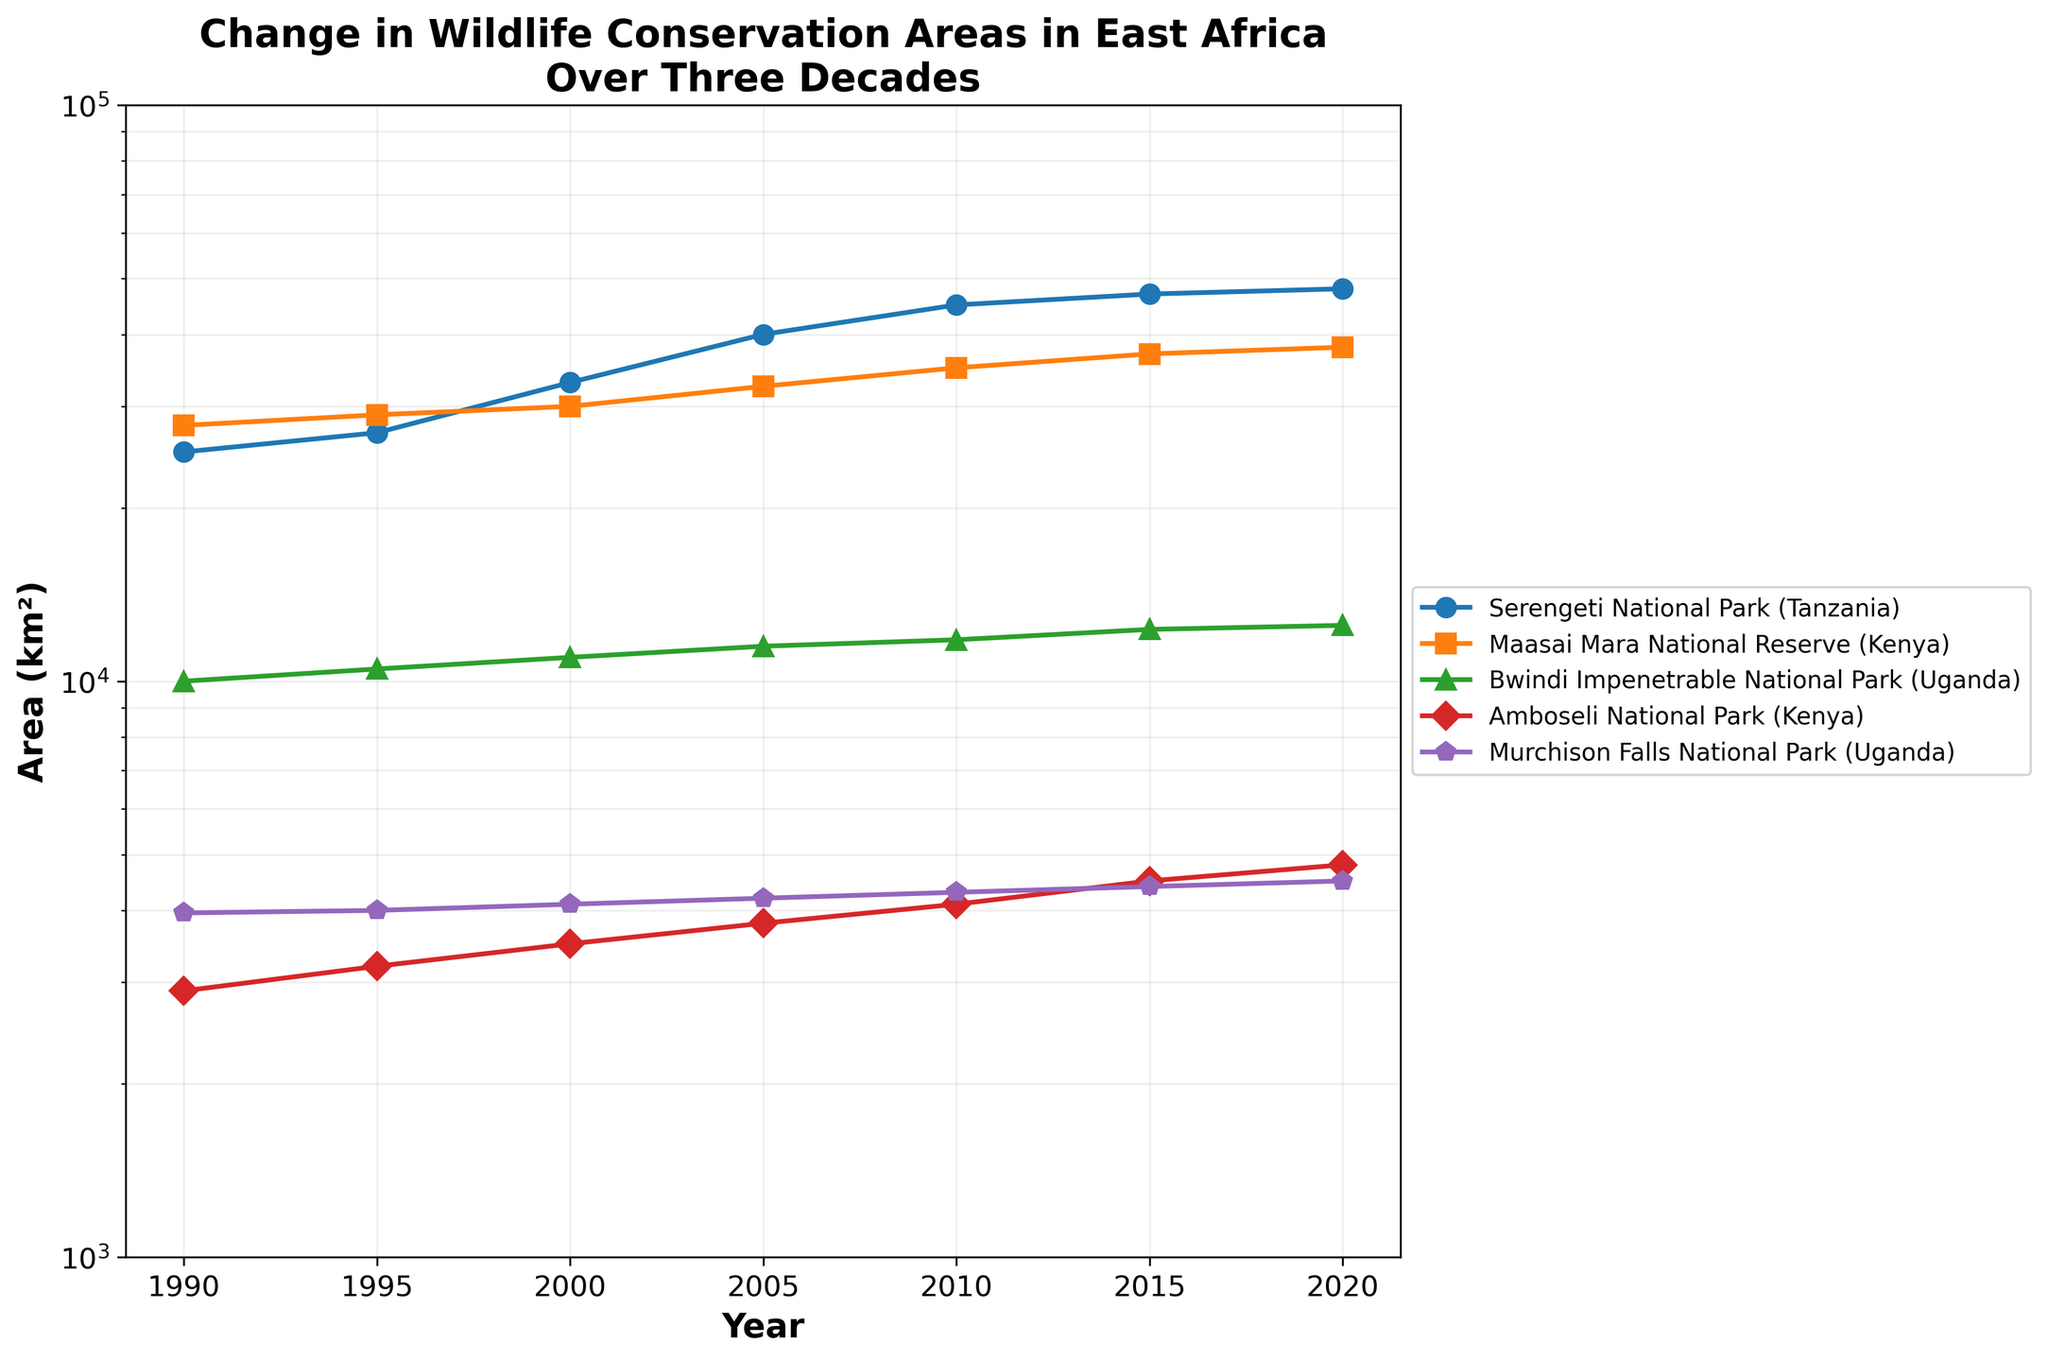What is the title of the figure? The title is prominently displayed at the top of the figure in bold font, describing the subject of the plot.
Answer: Change in Wildlife Conservation Areas in East Africa Over Three Decades Which national park had the largest conservation area in 2000? By looking at the 2000 data points on the plot for each park, we notice that Serengeti National Park has the highest value.
Answer: Serengeti National Park How many years are represented in the figure? Counting the data points on the x-axis, we see that there are seven different years represented.
Answer: 7 By how much did the area of Bwindi Impenetrable National Park increase from 1990 to 2020? The values for Bwindi Impenetrable National Park in 1990 and 2020 are 10,000 and 12,500 km² respectively. The increase is 12,500 - 10,000.
Answer: 2,500 km² Which park showed the most consistent increase over the years? By examining the slopes of the lines, Serengeti National Park displays a steady and significant increase without any decreases or plateaus.
Answer: Serengeti National Park Which conservation area had the smallest size in 1990? Looking at the data points for 1990 along the y-axis, Amboseli National Park has the smallest value.
Answer: Amboseli National Park In which year did Serengeti National Park surpass 40,000 km²? By following the Serengeti National Park line, it crosses the 40,000 km² threshold between 2000 and 2005. The closest year indicated is 2005.
Answer: 2005 Compare the size of Amboseli National Park in 2010 and 2015. What is the difference? Observing the data points, Amboseli National Park had areas of 4100 km² in 2010 and 4500 km² in 2015. The difference is 4500 - 4100.
Answer: 400 km² Does any national park show a decrease in area in any of the years? Examining the lines for irregularities or downward trends, we notice no park shows a decrease in area in any year.
Answer: No Which national park's size nears a logarithmic scale's lower limit of 1000 km²? Looking at the vertical axis and the plotted lines, Amboseli National Park's values are closest to but not falling below the lower limit of 1000 km².
Answer: Amboseli National Park 